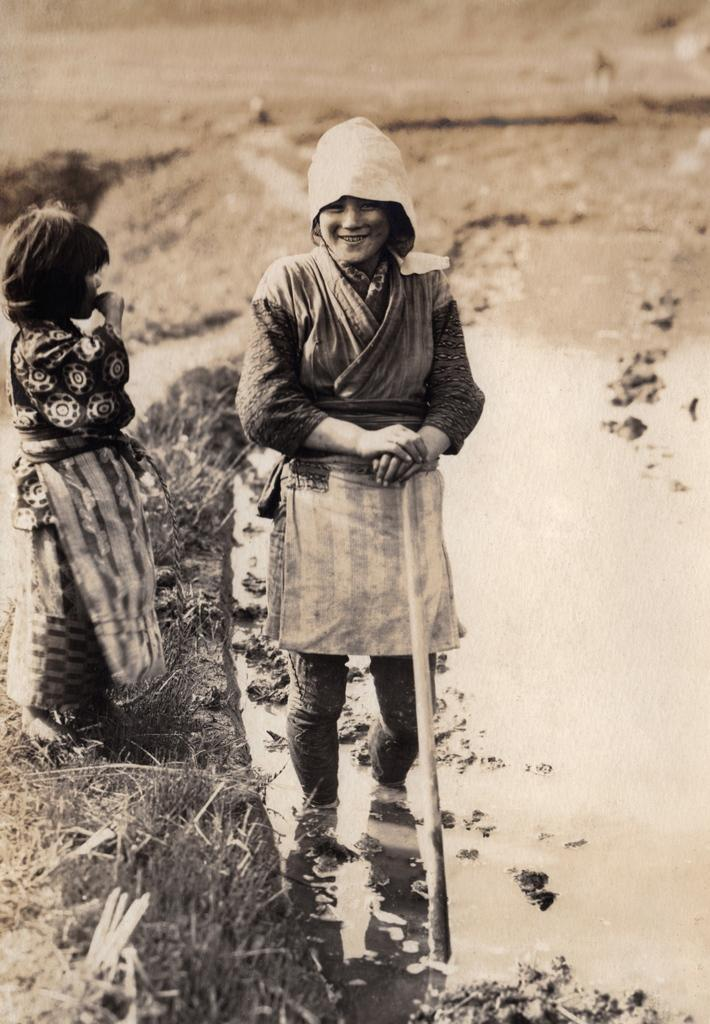What is the woman in the foreground of the image doing? The woman is standing in the mud in the foreground of the image. What is the woman holding in the image? The woman is holding a stick. Where is the girl located in the image? The girl is standing on the grass on the left side of the image. What can be seen in the background of the image? The land is visible in the background of the image. What type of work is the dad doing in the image? There is no dad present in the image, so it is not possible to determine what work he might be doing. What type of blade is the girl using to cut the grass in the image? There is no blade visible in the image, and the girl is not cutting the grass; she is simply standing on it. 